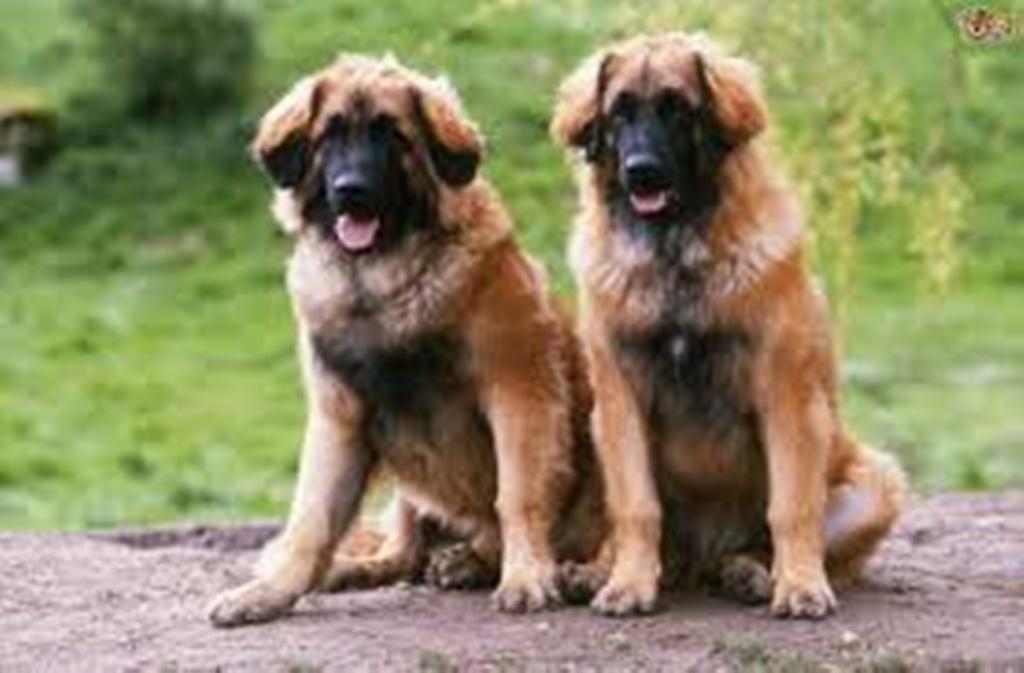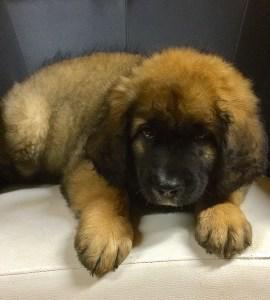The first image is the image on the left, the second image is the image on the right. For the images displayed, is the sentence "A dog is standing on the grass." factually correct? Answer yes or no. No. The first image is the image on the left, the second image is the image on the right. For the images shown, is this caption "An image shows one person to the left of a large dog." true? Answer yes or no. No. 